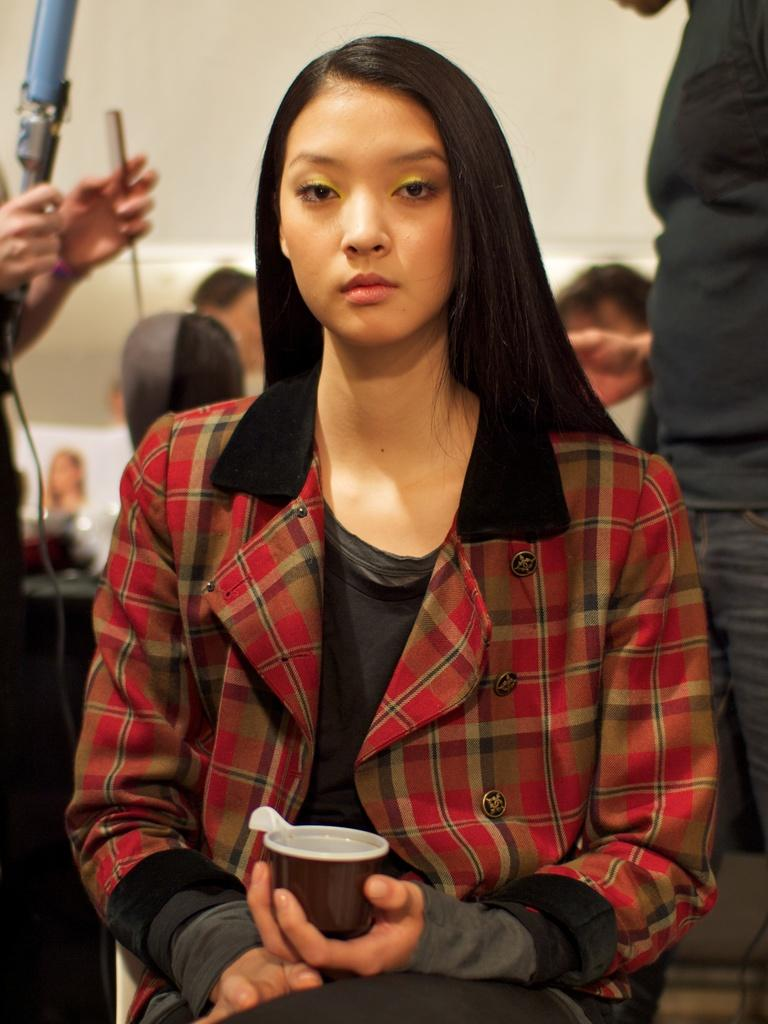Who is the main subject in the image? There is a woman in the image. What is the woman doing in the image? The woman is sitting. What is the woman holding in the image? The woman is holding a cup. Can you describe the background of the image? There are multiple people in the background of the image. What type of bean is being used in the apparatus in the image? There is no bean or apparatus present in the image. 